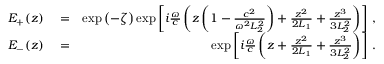<formula> <loc_0><loc_0><loc_500><loc_500>\begin{array} { r l r } { E _ { + } ( z ) } & = } & { \exp \left ( - \zeta \right ) \exp \left [ i \frac { \omega } { c } \left ( z \left ( 1 - \frac { c ^ { 2 } } { \omega ^ { 2 } L _ { 2 } ^ { 2 } } \right ) + \frac { z ^ { 2 } } { 2 L _ { 1 } } + \frac { z ^ { 3 } } { 3 L _ { 2 } ^ { 2 } } \right ) \right ] \, , } \\ { E _ { - } ( z ) } & = } & { \exp \left [ i \frac { \omega } { c } \left ( z + \frac { z ^ { 2 } } { 2 L _ { 1 } } + \frac { z ^ { 3 } } { 3 L _ { 2 } ^ { 2 } } \right ) \right ] \, . } \end{array}</formula> 